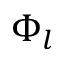<formula> <loc_0><loc_0><loc_500><loc_500>\Phi _ { l }</formula> 